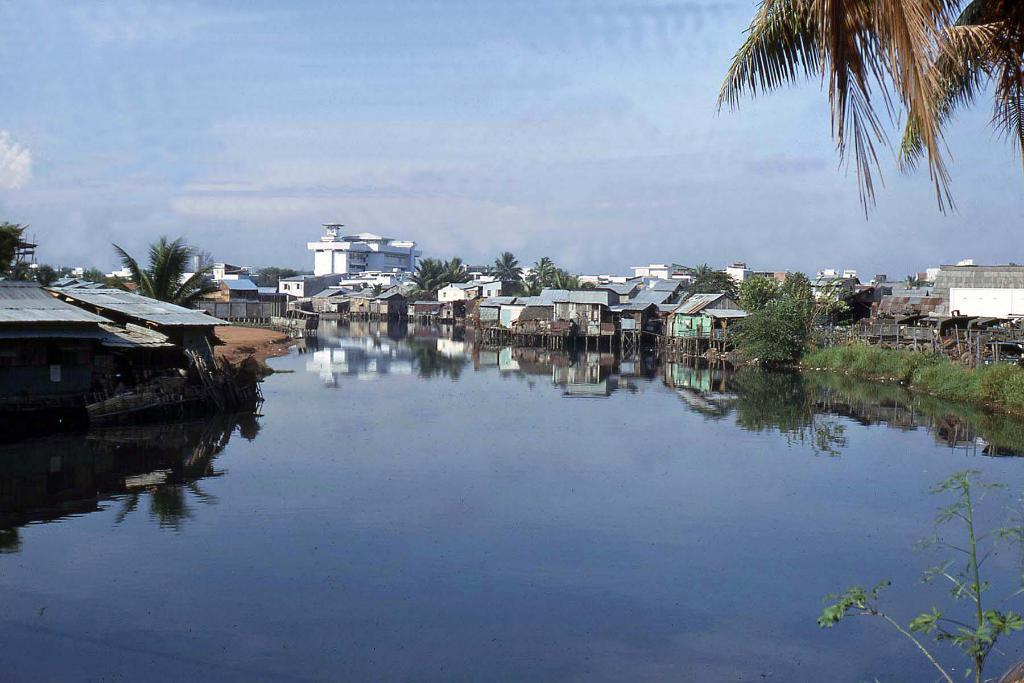What type of natural feature is present in the image? There is a river in the image. What can be seen on the left side of the river? There are buildings and trees on the left side of the river. What can be seen on the right side of the river? There are buildings and trees on the right side of the river. What is visible in the background of the image? The sky is visible in the background of the image. What month is it in the image? The month cannot be determined from the image, as it does not contain any information about the time of year. What grade is the pickle in the image? There is no pickle present in the image, so it cannot be graded. 